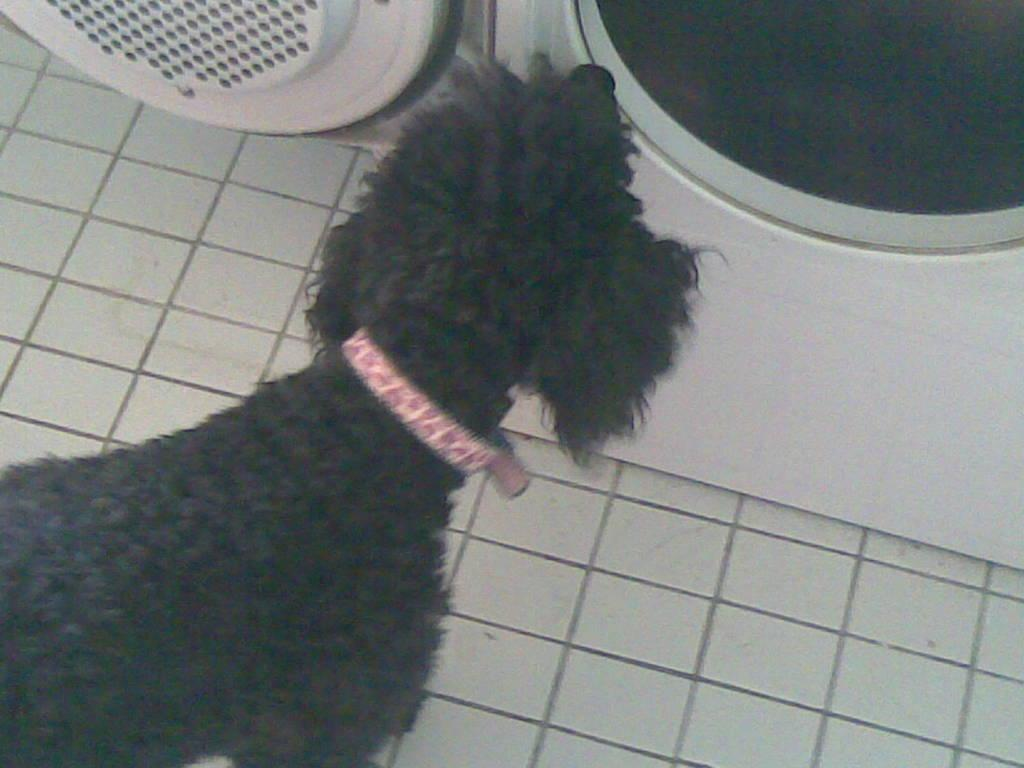What type of animal is in the image? There is a dog in the image. What color is the dog? The dog is black in color. What is the dog wearing around its neck? The dog has a pink belt around its neck. What appliance is present in the image? There is a washing machine in the image. What color is the washing machine? The washing machine is white in color. What color is the floor in the image? The floor in the image is white. What type of band is playing in the image? There is no band present in the image. 